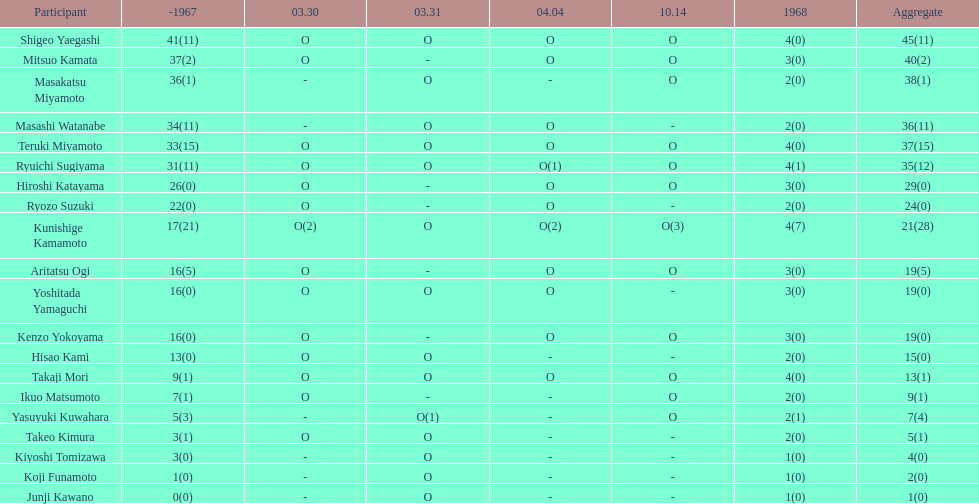Did mitsuo kamata have more than 40 total points? No. 